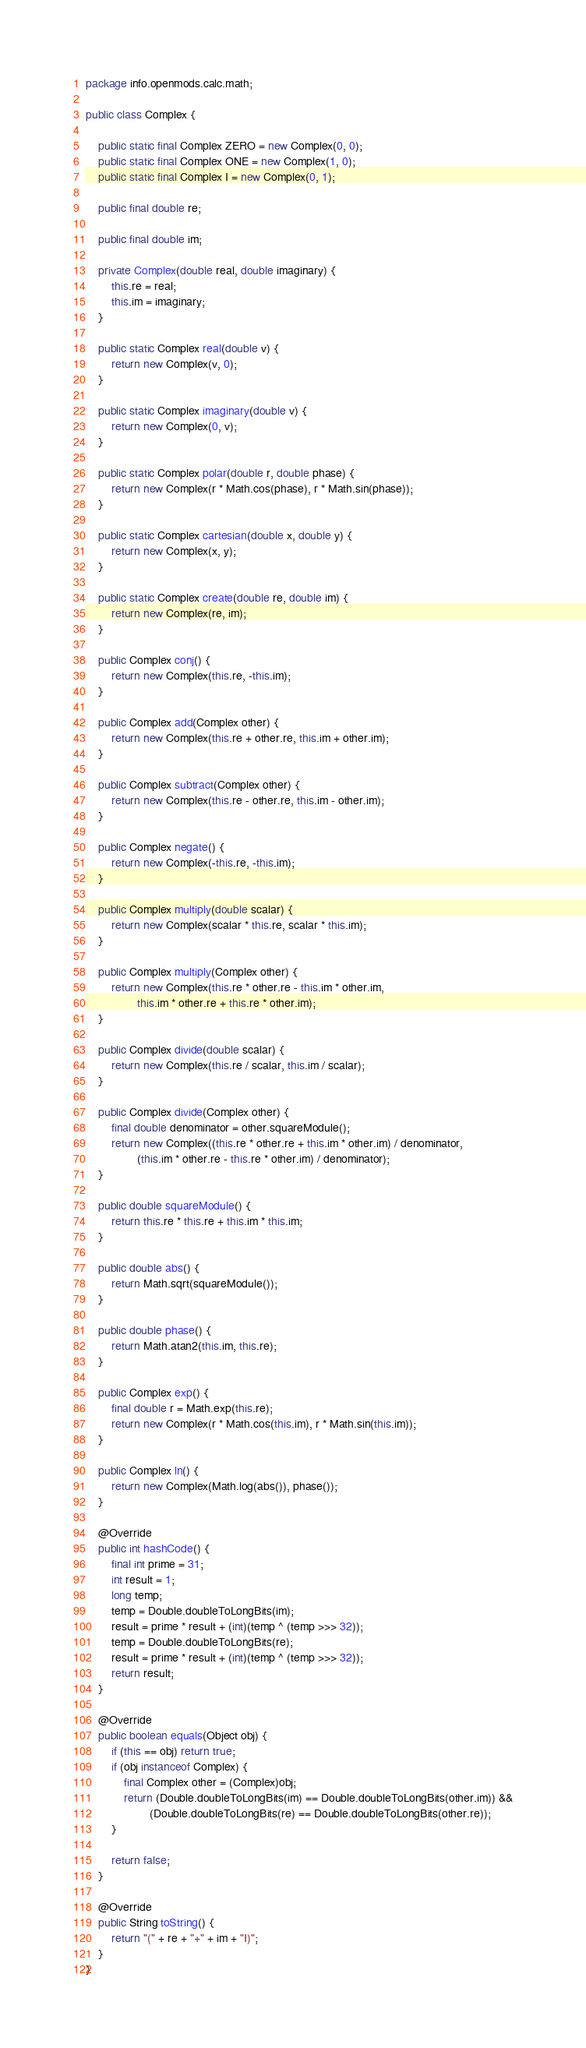<code> <loc_0><loc_0><loc_500><loc_500><_Java_>package info.openmods.calc.math;

public class Complex {

	public static final Complex ZERO = new Complex(0, 0);
	public static final Complex ONE = new Complex(1, 0);
	public static final Complex I = new Complex(0, 1);

	public final double re;

	public final double im;

	private Complex(double real, double imaginary) {
		this.re = real;
		this.im = imaginary;
	}

	public static Complex real(double v) {
		return new Complex(v, 0);
	}

	public static Complex imaginary(double v) {
		return new Complex(0, v);
	}

	public static Complex polar(double r, double phase) {
		return new Complex(r * Math.cos(phase), r * Math.sin(phase));
	}

	public static Complex cartesian(double x, double y) {
		return new Complex(x, y);
	}

	public static Complex create(double re, double im) {
		return new Complex(re, im);
	}

	public Complex conj() {
		return new Complex(this.re, -this.im);
	}

	public Complex add(Complex other) {
		return new Complex(this.re + other.re, this.im + other.im);
	}

	public Complex subtract(Complex other) {
		return new Complex(this.re - other.re, this.im - other.im);
	}

	public Complex negate() {
		return new Complex(-this.re, -this.im);
	}

	public Complex multiply(double scalar) {
		return new Complex(scalar * this.re, scalar * this.im);
	}

	public Complex multiply(Complex other) {
		return new Complex(this.re * other.re - this.im * other.im,
				this.im * other.re + this.re * other.im);
	}

	public Complex divide(double scalar) {
		return new Complex(this.re / scalar, this.im / scalar);
	}

	public Complex divide(Complex other) {
		final double denominator = other.squareModule();
		return new Complex((this.re * other.re + this.im * other.im) / denominator,
				(this.im * other.re - this.re * other.im) / denominator);
	}

	public double squareModule() {
		return this.re * this.re + this.im * this.im;
	}

	public double abs() {
		return Math.sqrt(squareModule());
	}

	public double phase() {
		return Math.atan2(this.im, this.re);
	}

	public Complex exp() {
		final double r = Math.exp(this.re);
		return new Complex(r * Math.cos(this.im), r * Math.sin(this.im));
	}

	public Complex ln() {
		return new Complex(Math.log(abs()), phase());
	}

	@Override
	public int hashCode() {
		final int prime = 31;
		int result = 1;
		long temp;
		temp = Double.doubleToLongBits(im);
		result = prime * result + (int)(temp ^ (temp >>> 32));
		temp = Double.doubleToLongBits(re);
		result = prime * result + (int)(temp ^ (temp >>> 32));
		return result;
	}

	@Override
	public boolean equals(Object obj) {
		if (this == obj) return true;
		if (obj instanceof Complex) {
			final Complex other = (Complex)obj;
			return (Double.doubleToLongBits(im) == Double.doubleToLongBits(other.im)) &&
					(Double.doubleToLongBits(re) == Double.doubleToLongBits(other.re));
		}

		return false;
	}

	@Override
	public String toString() {
		return "(" + re + "+" + im + "I)";
	}
}
</code> 